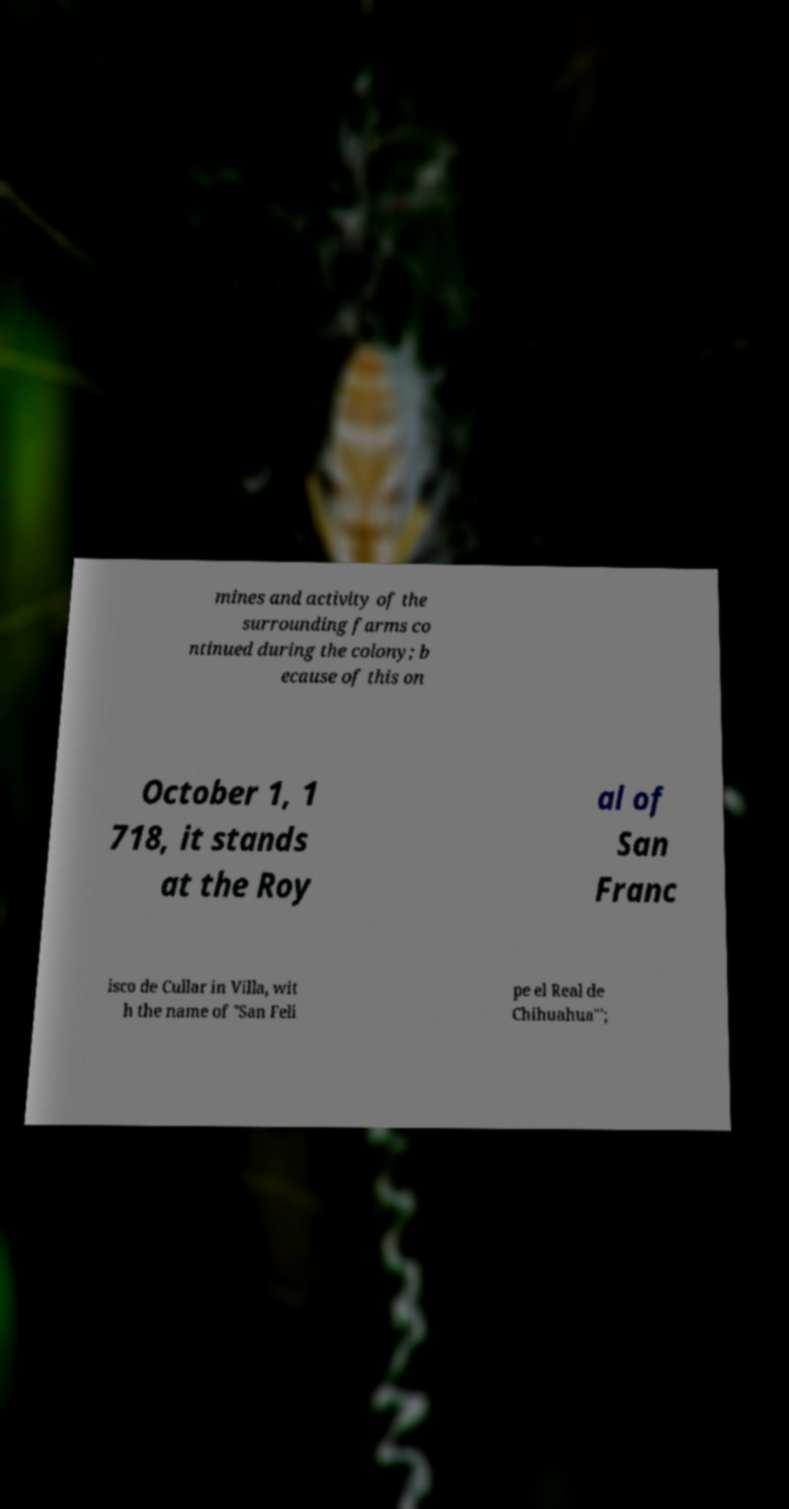For documentation purposes, I need the text within this image transcribed. Could you provide that? mines and activity of the surrounding farms co ntinued during the colony; b ecause of this on October 1, 1 718, it stands at the Roy al of San Franc isco de Cullar in Villa, wit h the name of "San Feli pe el Real de Chihuahua"'; 